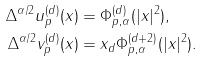Convert formula to latex. <formula><loc_0><loc_0><loc_500><loc_500>\Delta ^ { \alpha / 2 } u _ { p } ^ { ( d ) } ( x ) & = \Phi ^ { ( d ) } _ { p , \alpha } ( | x | ^ { 2 } ) , \\ \Delta ^ { \alpha / 2 } v _ { p } ^ { ( d ) } ( x ) & = x _ { d } \Phi ^ { ( d + 2 ) } _ { p , \alpha } ( | x | ^ { 2 } ) .</formula> 